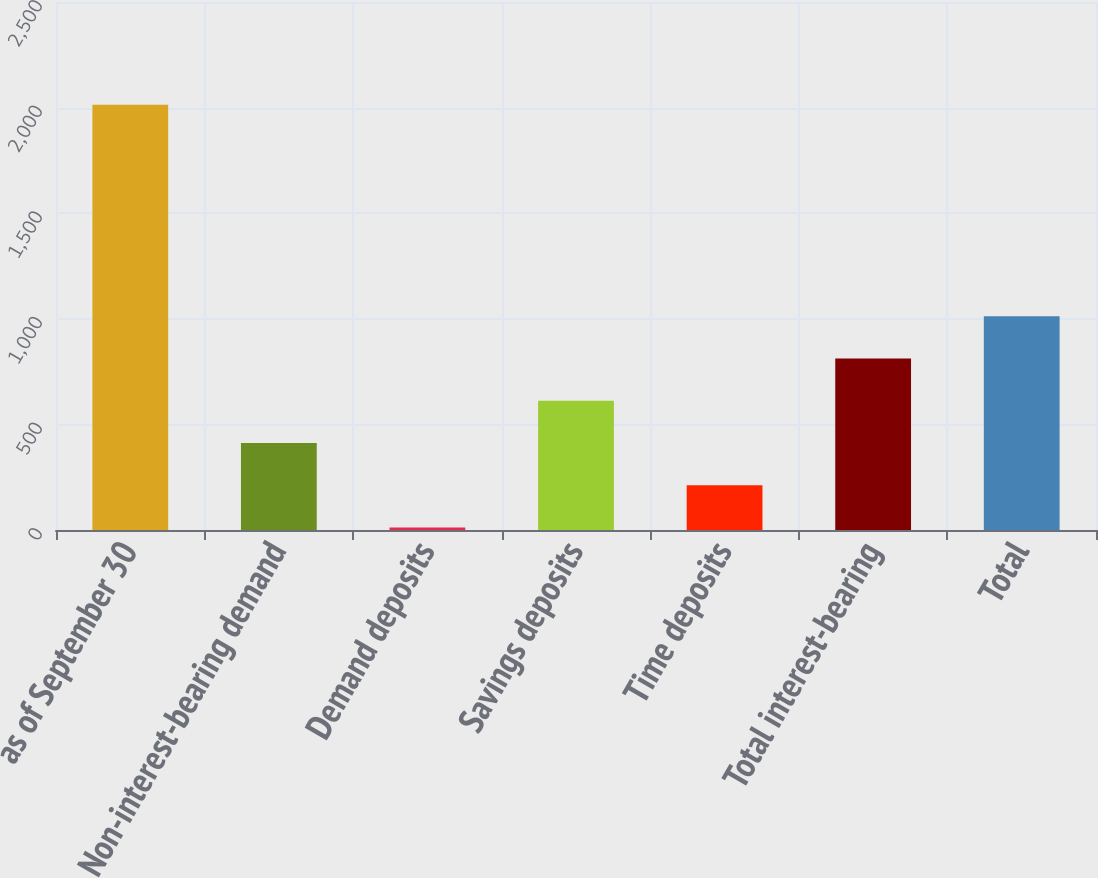Convert chart to OTSL. <chart><loc_0><loc_0><loc_500><loc_500><bar_chart><fcel>as of September 30<fcel>Non-interest-bearing demand<fcel>Demand deposits<fcel>Savings deposits<fcel>Time deposits<fcel>Total interest-bearing<fcel>Total<nl><fcel>2013<fcel>411.64<fcel>11.3<fcel>611.81<fcel>211.47<fcel>811.98<fcel>1012.15<nl></chart> 